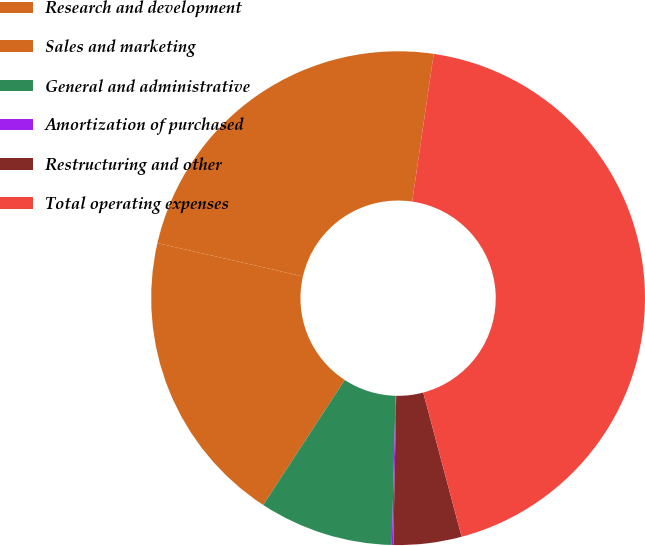Convert chart to OTSL. <chart><loc_0><loc_0><loc_500><loc_500><pie_chart><fcel>Research and development<fcel>Sales and marketing<fcel>General and administrative<fcel>Amortization of purchased<fcel>Restructuring and other<fcel>Total operating expenses<nl><fcel>23.72%<fcel>19.38%<fcel>8.79%<fcel>0.1%<fcel>4.45%<fcel>43.55%<nl></chart> 